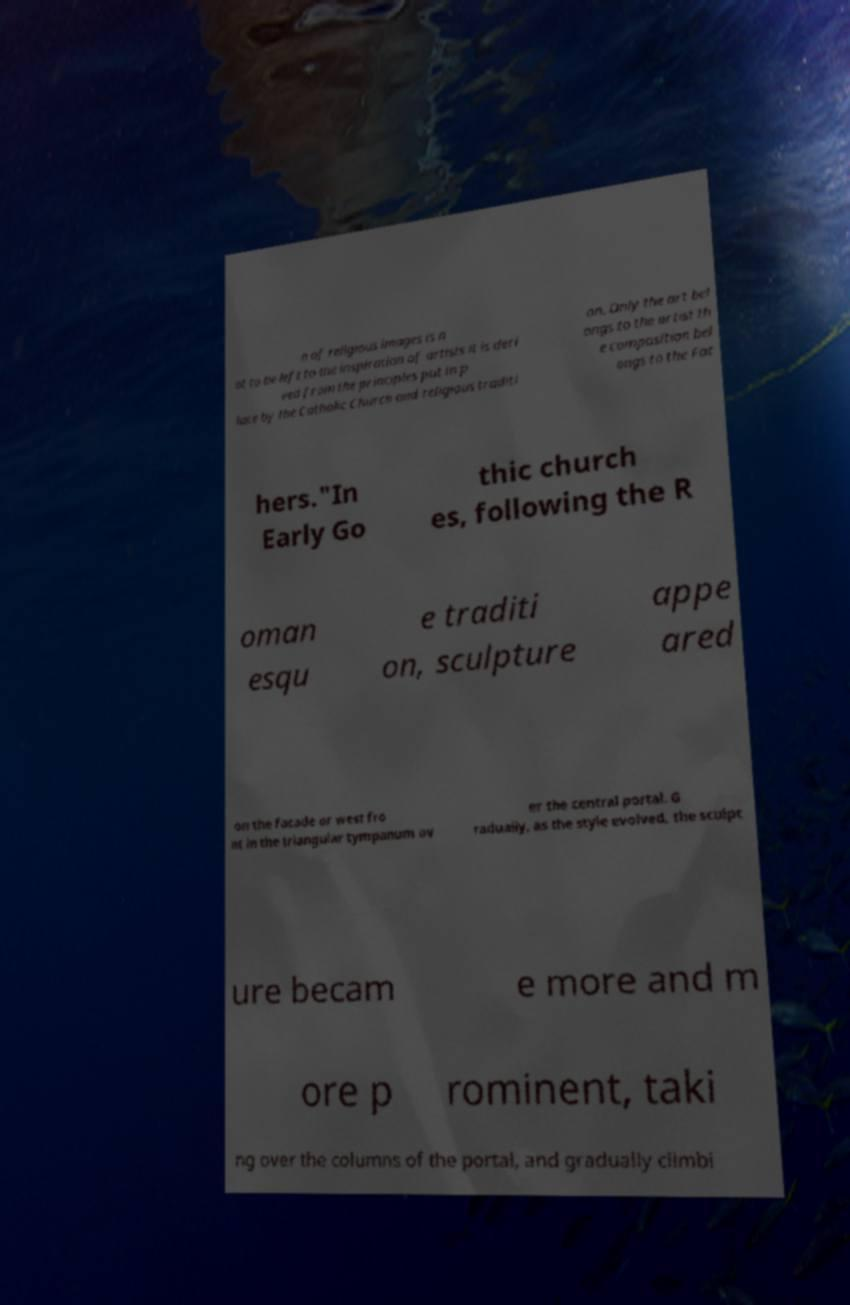Could you extract and type out the text from this image? n of religious images is n ot to be left to the inspiration of artists it is deri ved from the principles put in p lace by the Catholic Church and religious traditi on. Only the art bel ongs to the artist th e composition bel ongs to the Fat hers."In Early Go thic church es, following the R oman esqu e traditi on, sculpture appe ared on the facade or west fro nt in the triangular tympanum ov er the central portal. G radually, as the style evolved, the sculpt ure becam e more and m ore p rominent, taki ng over the columns of the portal, and gradually climbi 